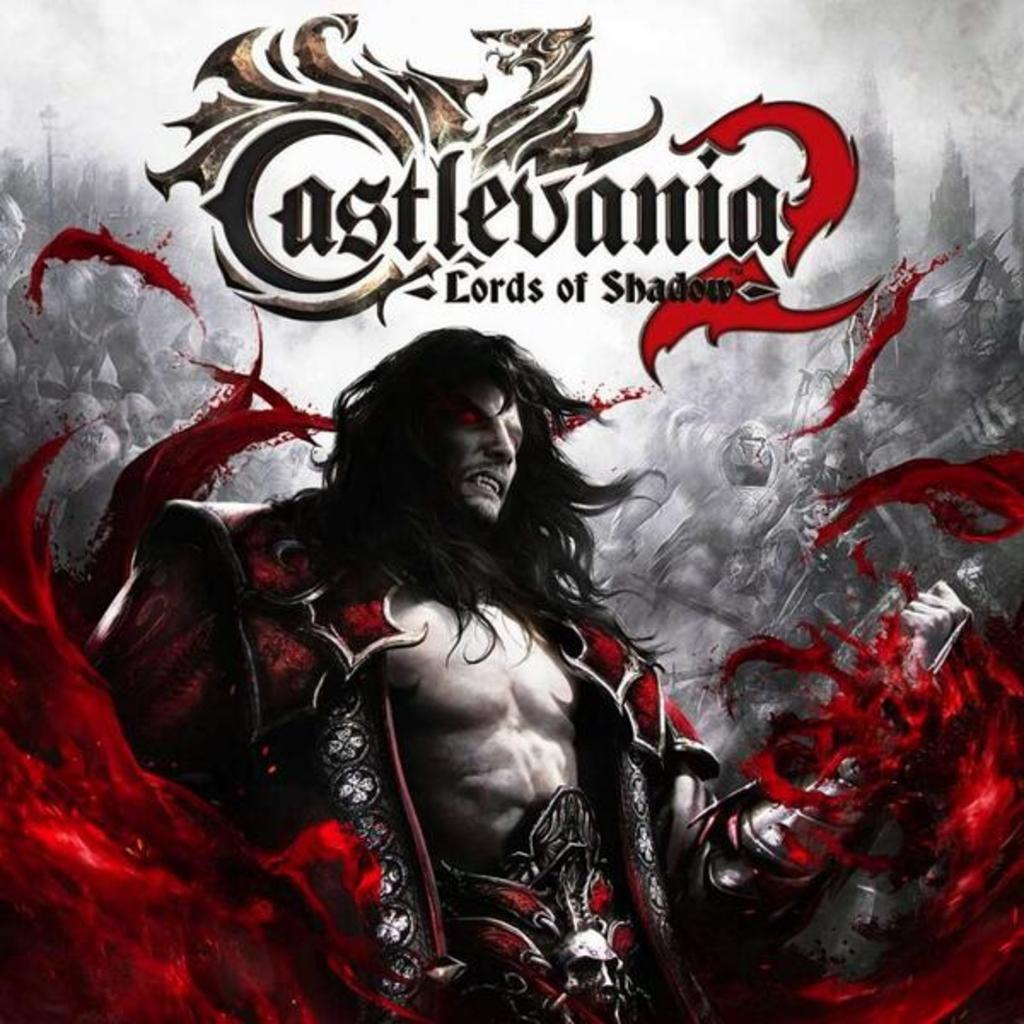What is the main object in the image? There is a pamphlet in the image. What is happening in the image involving the pamphlet? A person is standing in the pamphlet. What can be found on the pamphlet besides the person? There is text written on the pamphlet. How many bikes are parked next to the person in the image? There is no bike present in the image; it only features a person standing in a pamphlet with text. What scientific reason can be deduced from the image? The image does not provide any scientific information or reason to deduce. 